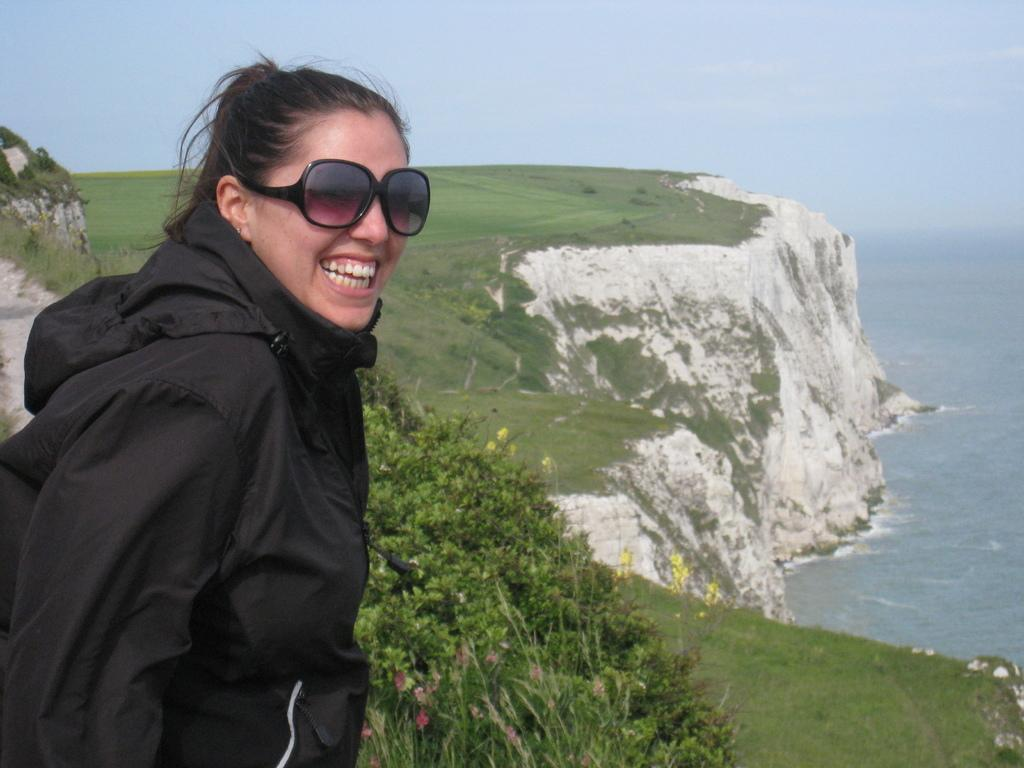Who is present in the image? There is a woman in the image. Where is the woman located? The woman is standing on a mountain. What can be seen on the mountain? The mountain is filled with grass and plants. What is visible in the background of the image? There is a sea visible in the background of the image. What type of sock is the woman wearing in the image? There is no information about the woman's socks in the image, so it cannot be determined. 